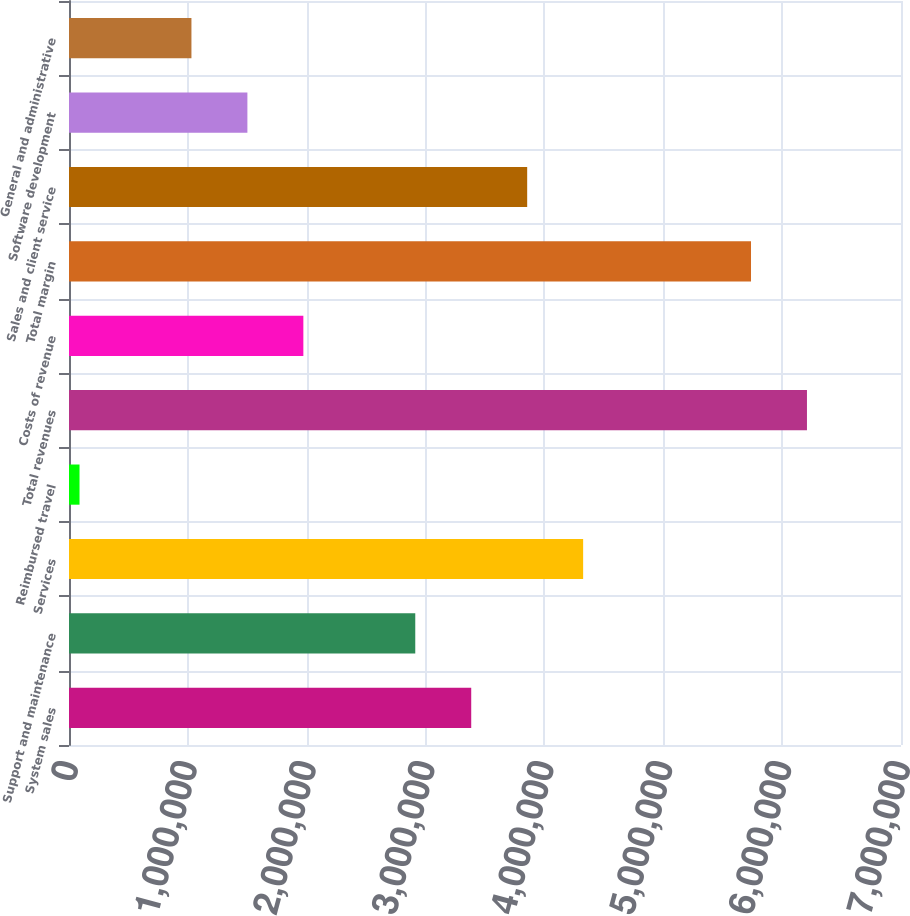Convert chart to OTSL. <chart><loc_0><loc_0><loc_500><loc_500><bar_chart><fcel>System sales<fcel>Support and maintenance<fcel>Services<fcel>Reimbursed travel<fcel>Total revenues<fcel>Costs of revenue<fcel>Total margin<fcel>Sales and client service<fcel>Software development<fcel>General and administrative<nl><fcel>3.38409e+06<fcel>2.9133e+06<fcel>4.32568e+06<fcel>88545<fcel>6.20885e+06<fcel>1.97172e+06<fcel>5.73806e+06<fcel>3.85489e+06<fcel>1.50092e+06<fcel>1.03013e+06<nl></chart> 